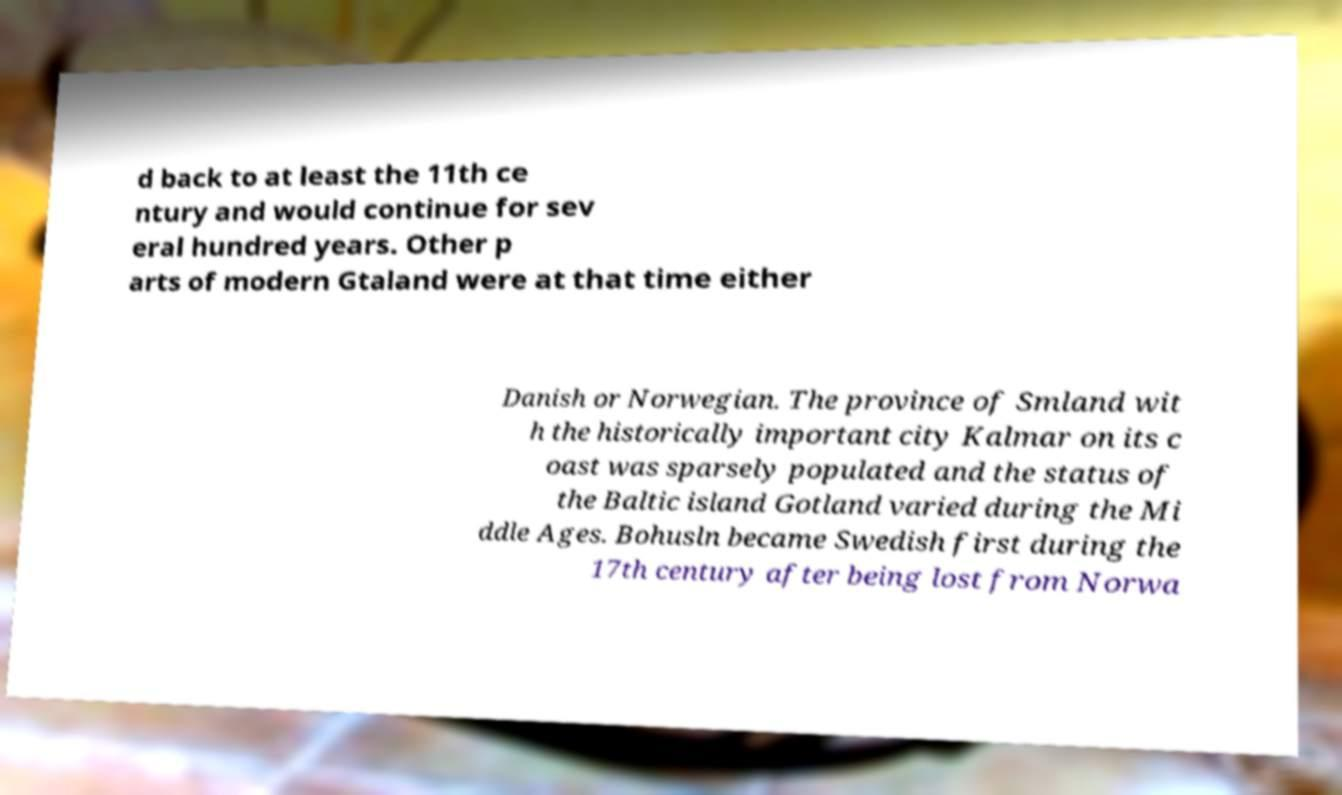There's text embedded in this image that I need extracted. Can you transcribe it verbatim? d back to at least the 11th ce ntury and would continue for sev eral hundred years. Other p arts of modern Gtaland were at that time either Danish or Norwegian. The province of Smland wit h the historically important city Kalmar on its c oast was sparsely populated and the status of the Baltic island Gotland varied during the Mi ddle Ages. Bohusln became Swedish first during the 17th century after being lost from Norwa 